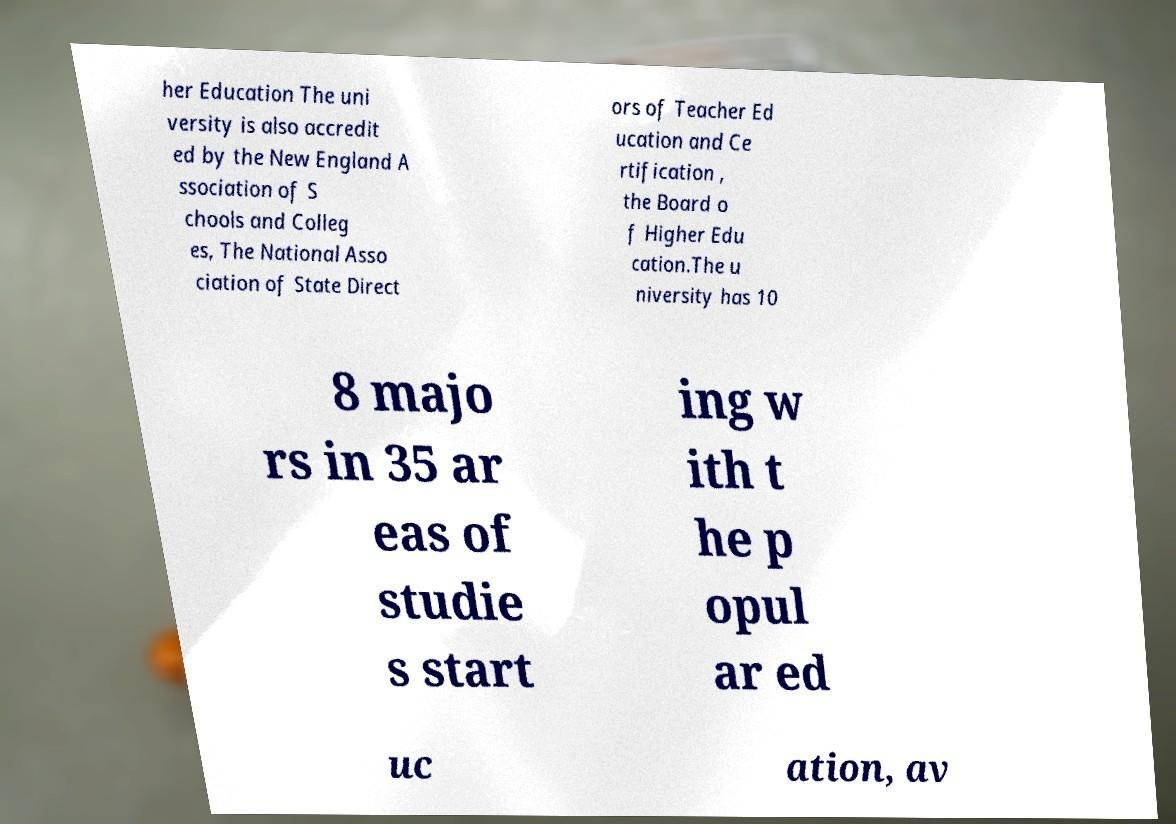Could you assist in decoding the text presented in this image and type it out clearly? her Education The uni versity is also accredit ed by the New England A ssociation of S chools and Colleg es, The National Asso ciation of State Direct ors of Teacher Ed ucation and Ce rtification , the Board o f Higher Edu cation.The u niversity has 10 8 majo rs in 35 ar eas of studie s start ing w ith t he p opul ar ed uc ation, av 